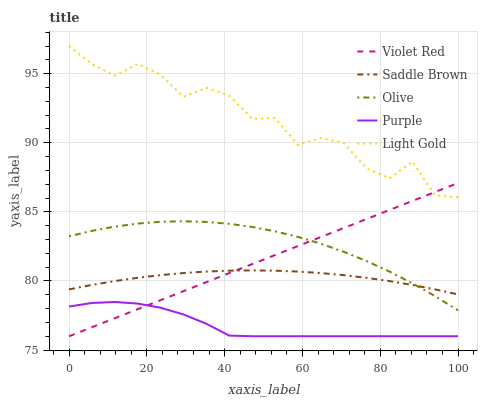Does Purple have the minimum area under the curve?
Answer yes or no. Yes. Does Light Gold have the maximum area under the curve?
Answer yes or no. Yes. Does Violet Red have the minimum area under the curve?
Answer yes or no. No. Does Violet Red have the maximum area under the curve?
Answer yes or no. No. Is Violet Red the smoothest?
Answer yes or no. Yes. Is Light Gold the roughest?
Answer yes or no. Yes. Is Purple the smoothest?
Answer yes or no. No. Is Purple the roughest?
Answer yes or no. No. Does Purple have the lowest value?
Answer yes or no. Yes. Does Light Gold have the lowest value?
Answer yes or no. No. Does Light Gold have the highest value?
Answer yes or no. Yes. Does Violet Red have the highest value?
Answer yes or no. No. Is Purple less than Olive?
Answer yes or no. Yes. Is Olive greater than Purple?
Answer yes or no. Yes. Does Violet Red intersect Purple?
Answer yes or no. Yes. Is Violet Red less than Purple?
Answer yes or no. No. Is Violet Red greater than Purple?
Answer yes or no. No. Does Purple intersect Olive?
Answer yes or no. No. 